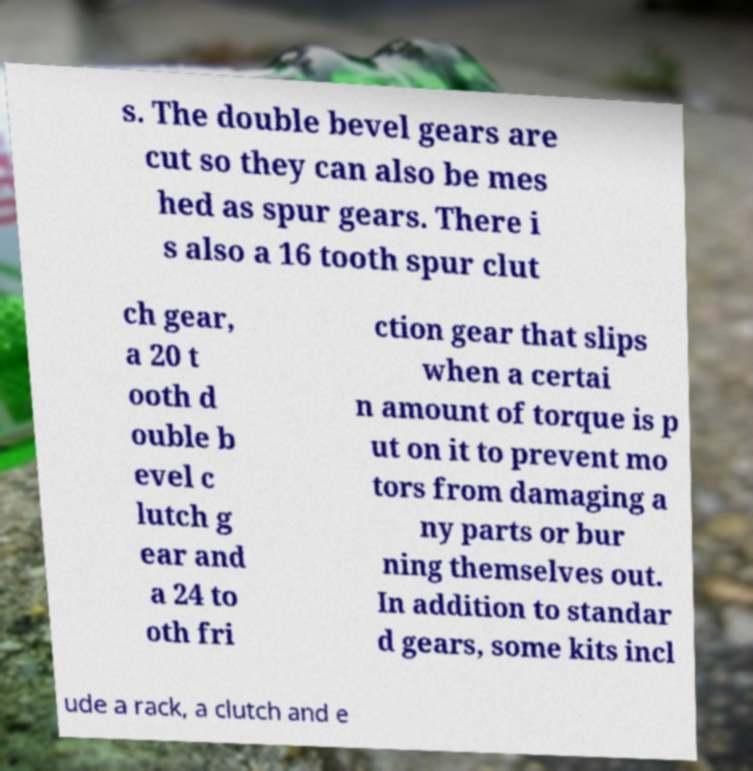For documentation purposes, I need the text within this image transcribed. Could you provide that? s. The double bevel gears are cut so they can also be mes hed as spur gears. There i s also a 16 tooth spur clut ch gear, a 20 t ooth d ouble b evel c lutch g ear and a 24 to oth fri ction gear that slips when a certai n amount of torque is p ut on it to prevent mo tors from damaging a ny parts or bur ning themselves out. In addition to standar d gears, some kits incl ude a rack, a clutch and e 